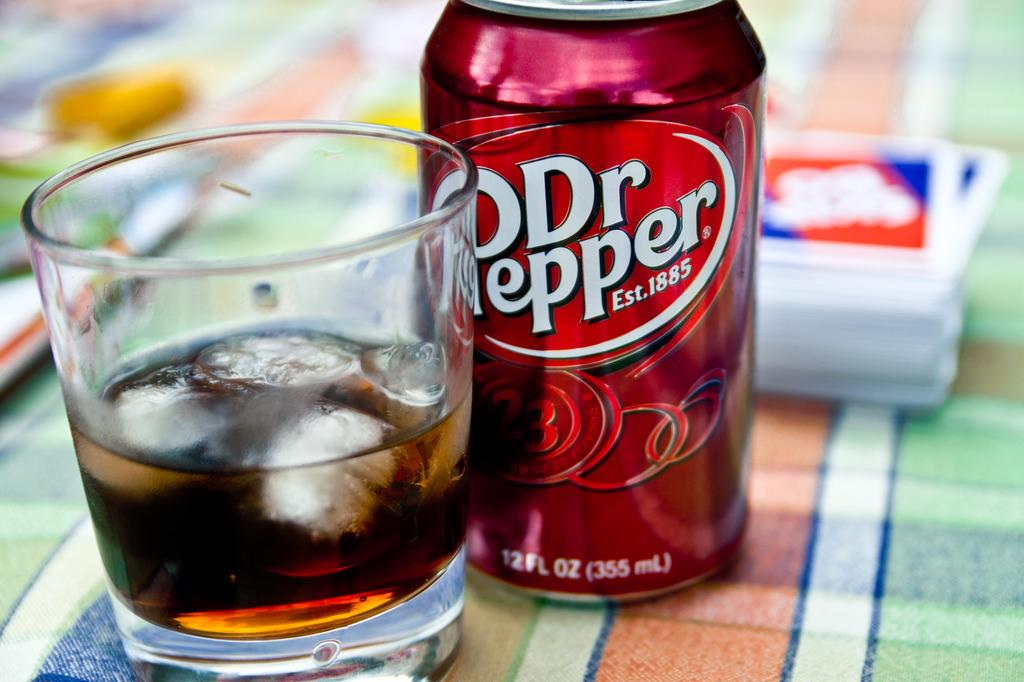<image>
Create a compact narrative representing the image presented. A can of Dr. Pepper next to a glass half full of Dr. Pepper. 